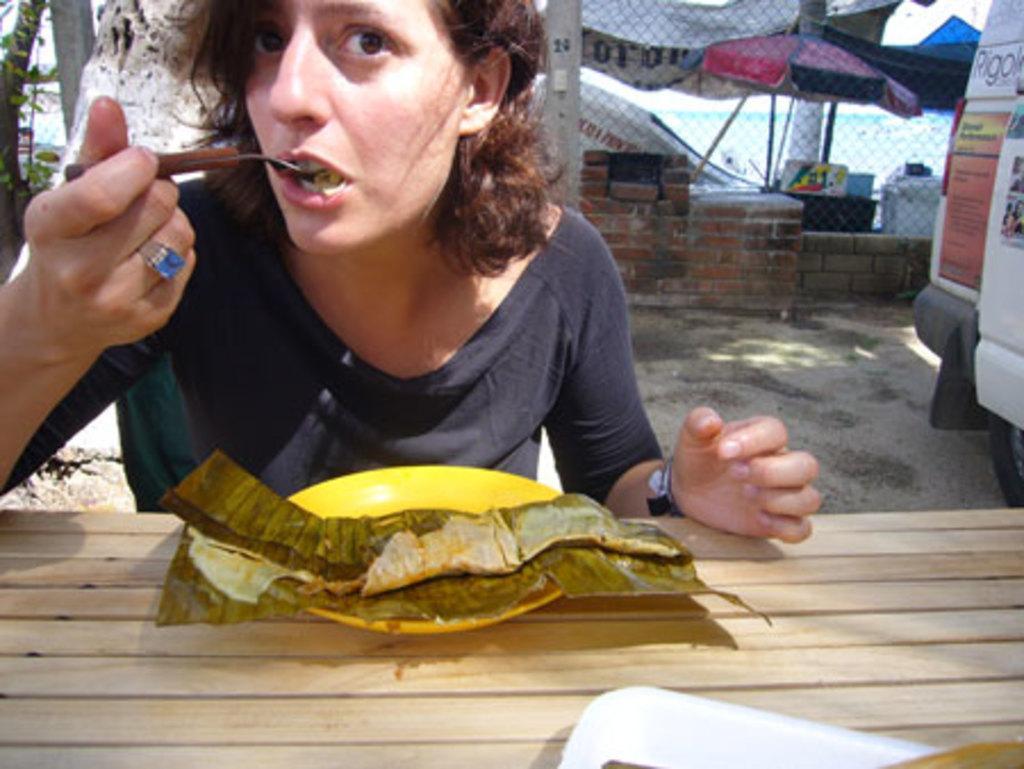How would you summarize this image in a sentence or two? In this picture I can see a woman in front who is holding a spoon and I see a table in front of her on which there is a yellow plate and I see a leaf on it. In the background the path and the wall and I see few stalls. 